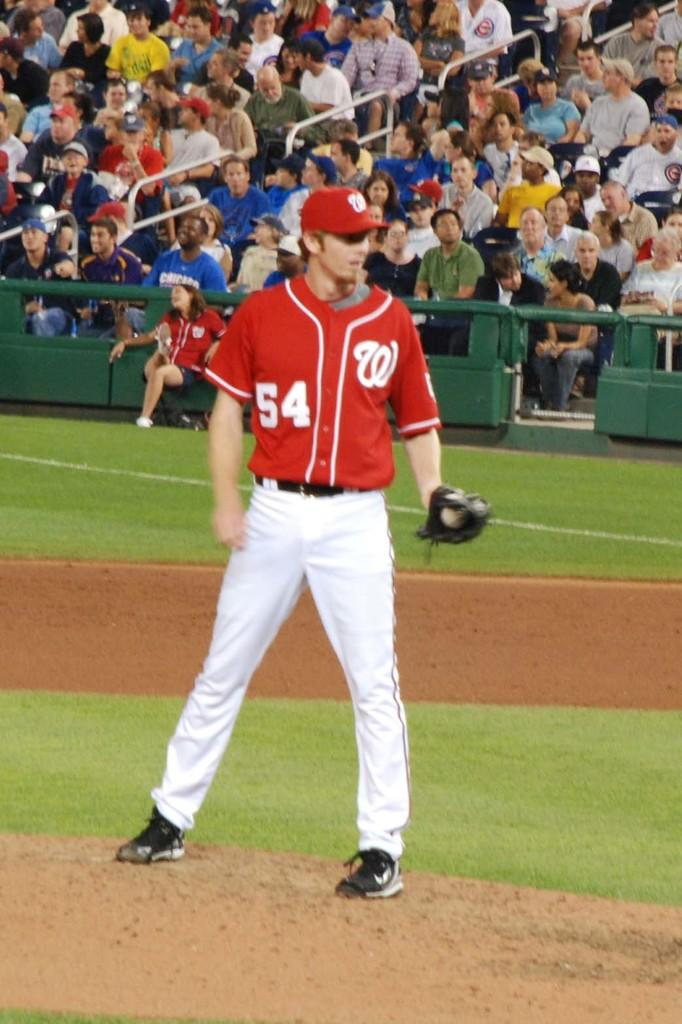<image>
Relay a brief, clear account of the picture shown. A pitcher wearing number 54 on his jersey is standing on the mound. 